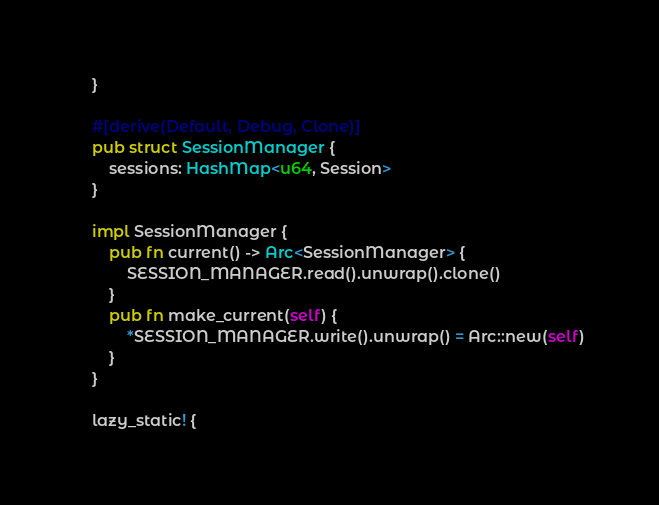Convert code to text. <code><loc_0><loc_0><loc_500><loc_500><_Rust_>    }

    #[derive(Default, Debug, Clone)]
    pub struct SessionManager {
        sessions: HashMap<u64, Session>
    }

    impl SessionManager {
        pub fn current() -> Arc<SessionManager> {
            SESSION_MANAGER.read().unwrap().clone()
        }
        pub fn make_current(self) {
            *SESSION_MANAGER.write().unwrap() = Arc::new(self)
        }
    }

    lazy_static! {</code> 